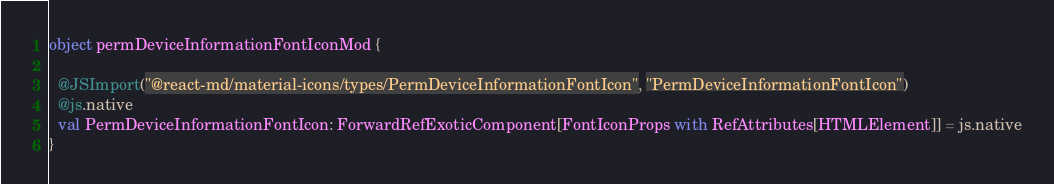<code> <loc_0><loc_0><loc_500><loc_500><_Scala_>object permDeviceInformationFontIconMod {
  
  @JSImport("@react-md/material-icons/types/PermDeviceInformationFontIcon", "PermDeviceInformationFontIcon")
  @js.native
  val PermDeviceInformationFontIcon: ForwardRefExoticComponent[FontIconProps with RefAttributes[HTMLElement]] = js.native
}
</code> 